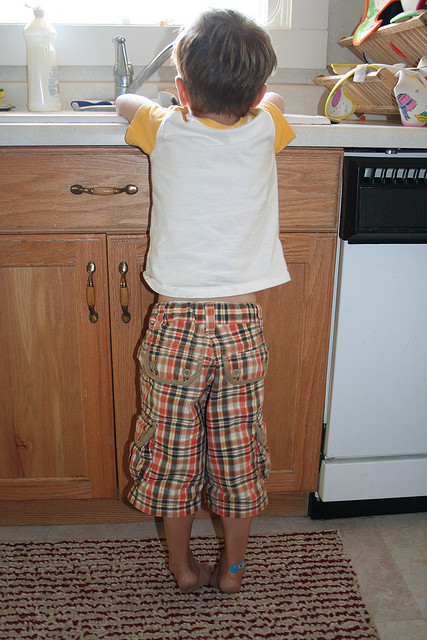<image>What appliance is the boy standing next to? I am not sure what appliance the boy is standing next to. However, it can be a dishwasher. What appliance is the boy standing next to? The boy is standing next to a dishwasher. 